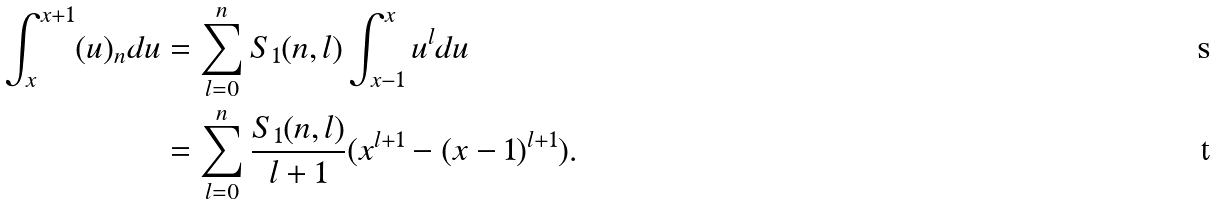<formula> <loc_0><loc_0><loc_500><loc_500>\int _ { x } ^ { x + 1 } ( u ) _ { n } d u & = \sum _ { l = 0 } ^ { n } S _ { 1 } ( n , l ) \int _ { x - 1 } ^ { x } u ^ { l } d u \\ & = \sum _ { l = 0 } ^ { n } \frac { S _ { 1 } ( n , l ) } { l + 1 } ( x ^ { l + 1 } - ( x - 1 ) ^ { l + 1 } ) .</formula> 